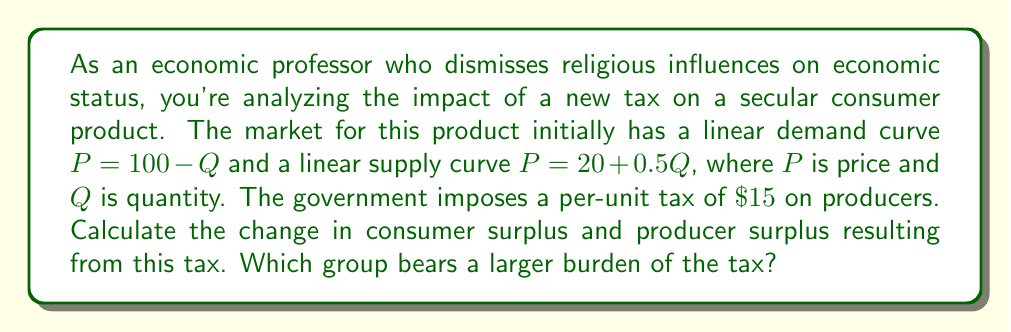What is the answer to this math problem? Let's approach this step-by-step:

1) First, we need to find the equilibrium price and quantity before the tax:
   $100 - Q = 20 + 0.5Q$
   $80 = 1.5Q$
   $Q = 53.33$
   $P = 100 - 53.33 = \$46.67$

2) After the tax, the supply curve shifts up by $\$15$:
   New supply curve: $P = 35 + 0.5Q$

3) New equilibrium:
   $100 - Q = 35 + 0.5Q$
   $65 = 1.5Q$
   $Q = 43.33$
   $P = 100 - 43.33 = \$56.67$

4) Price paid by consumers: $\$56.67$
   Price received by producers: $\$56.67 - \$15 = \$41.67$

5) Change in Consumer Surplus (CS):
   $\Delta CS = -\frac{1}{2}(56.67 - 46.67)(53.33 - 43.33) = -\$50$

6) Change in Producer Surplus (PS):
   $\Delta PS = -\frac{1}{2}(46.67 - 41.67)(53.33 + 43.33) - 15 * 43.33 = -\$675$

7) The total burden of the tax is $\$725$, of which consumers bear $\$50$ and producers bear $\$675$.
Answer: The change in consumer surplus is $-\$50$, and the change in producer surplus is $-\$675$. Producers bear a larger burden of the tax, accounting for approximately 93% of the total tax burden. 